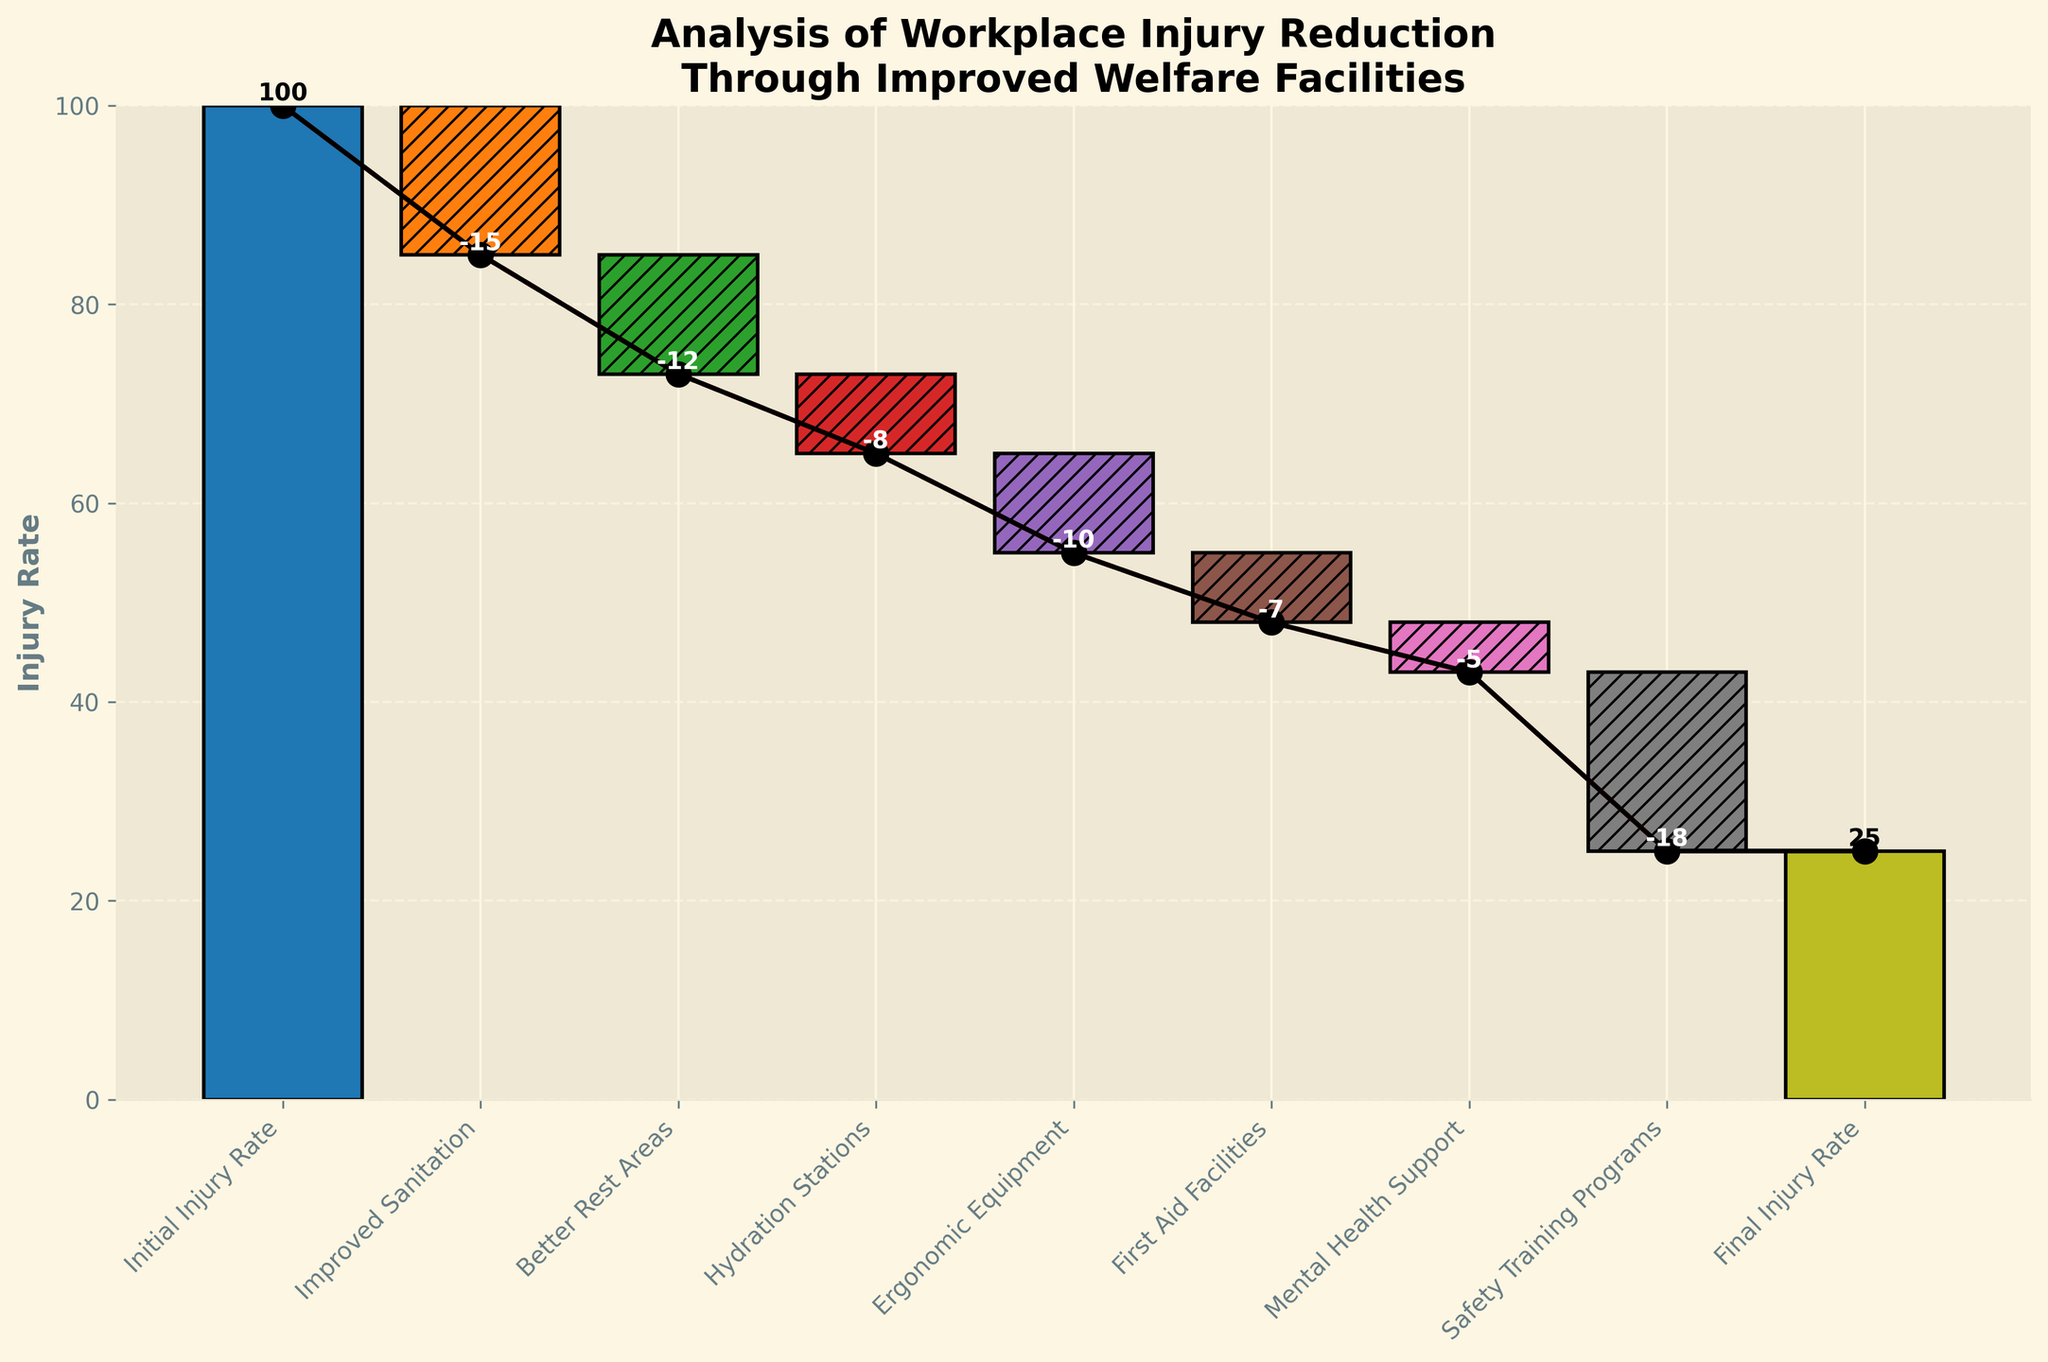What's the title of the waterfall chart? The title is located at the top of the figure, describing the overall theme of the chart.
Answer: Analysis of Workplace Injury Reduction Through Improved Welfare Facilities How many categories are displayed on the x-axis? Count the number of distinct categories labeled on the x-axis.
Answer: 9 Which welfare improvement category contributed to the highest reduction in injury rates? Identify the category with the largest negative value (indicating the highest reduction) in the bars of the chart.
Answer: Safety Training Programs What is the final injury rate after all the improvements? Look at the value associated with the 'Final Injury Rate' category at the end of the waterfall chart.
Answer: 25 How did the introduction of 'Ergonomic Equipment' affect the injury rate? Check the change in injury rate associated with the 'Ergonomic Equipment' category by observing its corresponding bar.
Answer: -10 What is the total reduction in injury rate contributed by 'Improved Sanitation' and 'Better Rest Areas'? Sum the reductions from 'Improved Sanitation' and 'Better Rest Areas' (-15 and -12 respectively). Calculate: -15 + -12 = -27
Answer: -27 By how much did 'Mental Health Support' contribute to reducing the injury rate? Read the exact value shown for 'Mental Health Support' on its bar in the chart.
Answer: -5 Which had a greater impact on reducing injuries: 'Hydration Stations' or 'First Aid Facilities'? Compare the values associated with 'Hydration Stations' (-8) and 'First Aid Facilities' (-7) to see which has a larger negative effect.
Answer: Hydration Stations What was the cumulative injury rate reduction after implementing 'First Aid Facilities'? Sum the cumulative reductions up to and including 'First Aid Facilities': 100 - 15 - 12 - 8 - 10 - 7. Calculate: 100 - 15 = 85, 85 - 12 = 73, 73 - 8 = 65, 65 - 10 = 55, 55 - 7 = 48
Answer: 48 Can you list all categories that show a reduction in injury rates? Identify all categories with negative values associated with them in the waterfall chart.
Answer: Improved Sanitation, Better Rest Areas, Hydration Stations, Ergonomic Equipment, First Aid Facilities, Mental Health Support, Safety Training Programs 